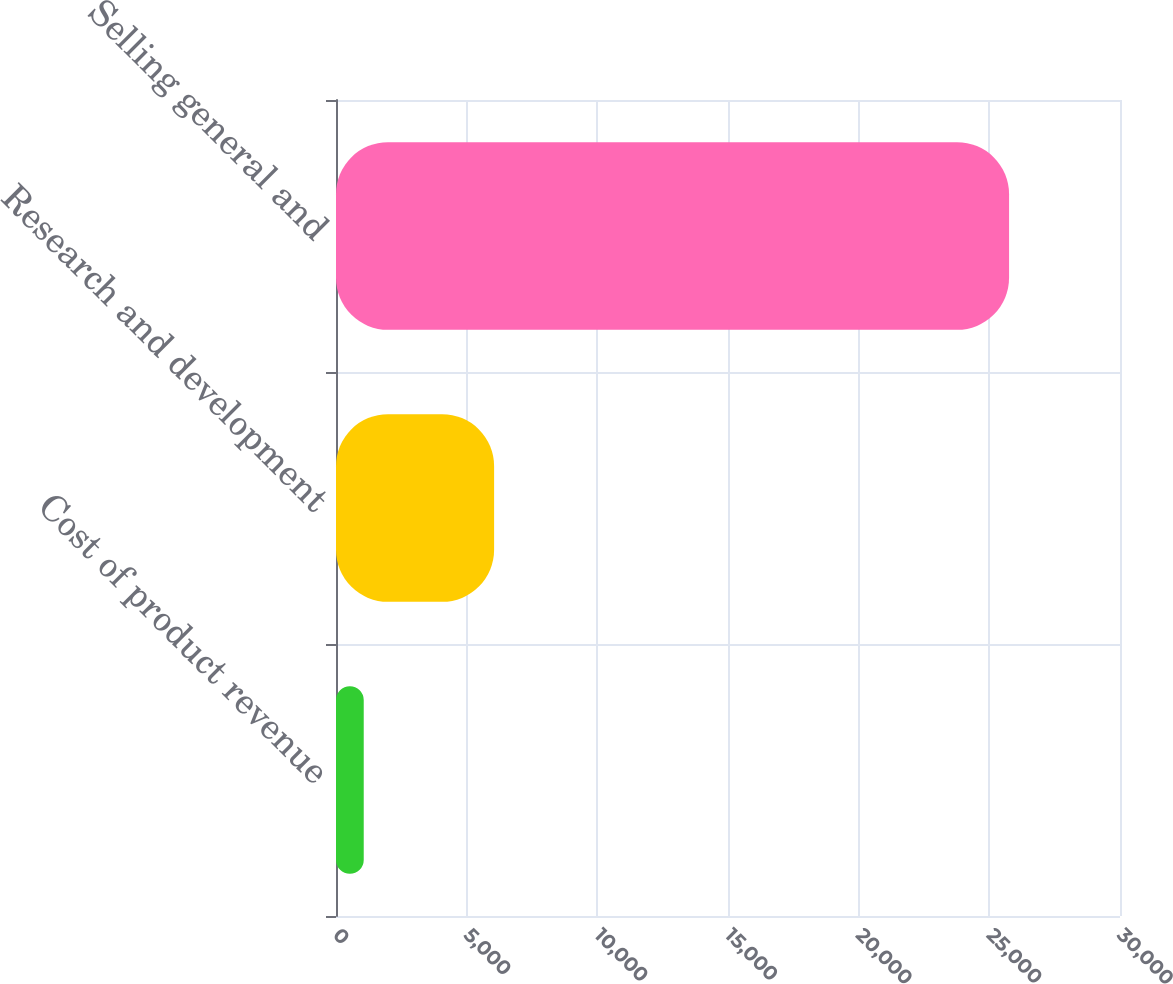<chart> <loc_0><loc_0><loc_500><loc_500><bar_chart><fcel>Cost of product revenue<fcel>Research and development<fcel>Selling general and<nl><fcel>1061<fcel>6050<fcel>25755<nl></chart> 